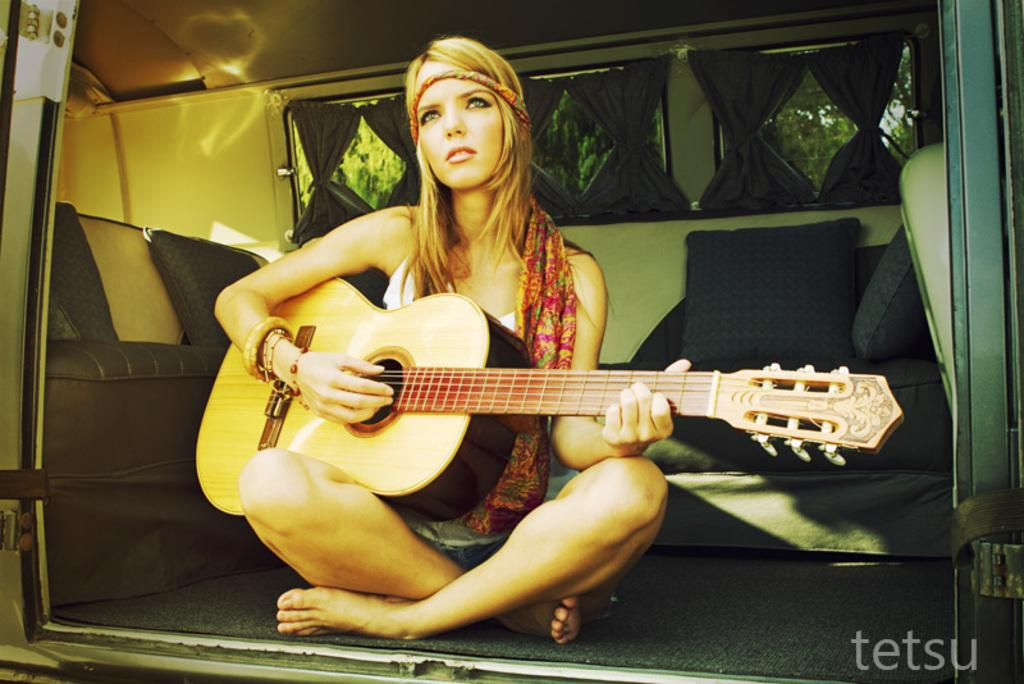Who is the main subject in the image? There is a woman in the image. What is the woman doing in the image? The woman is sitting on a carpet and playing a guitar. What other objects can be seen in the image? There are pillows and a glass visible in the image. What is visible in the background of the image? Trees are visible in the background of the image. What type of paste is being used to print the woman's image? There is no paste or printing involved in the image; it is a photograph or digital representation of the woman playing a guitar. 